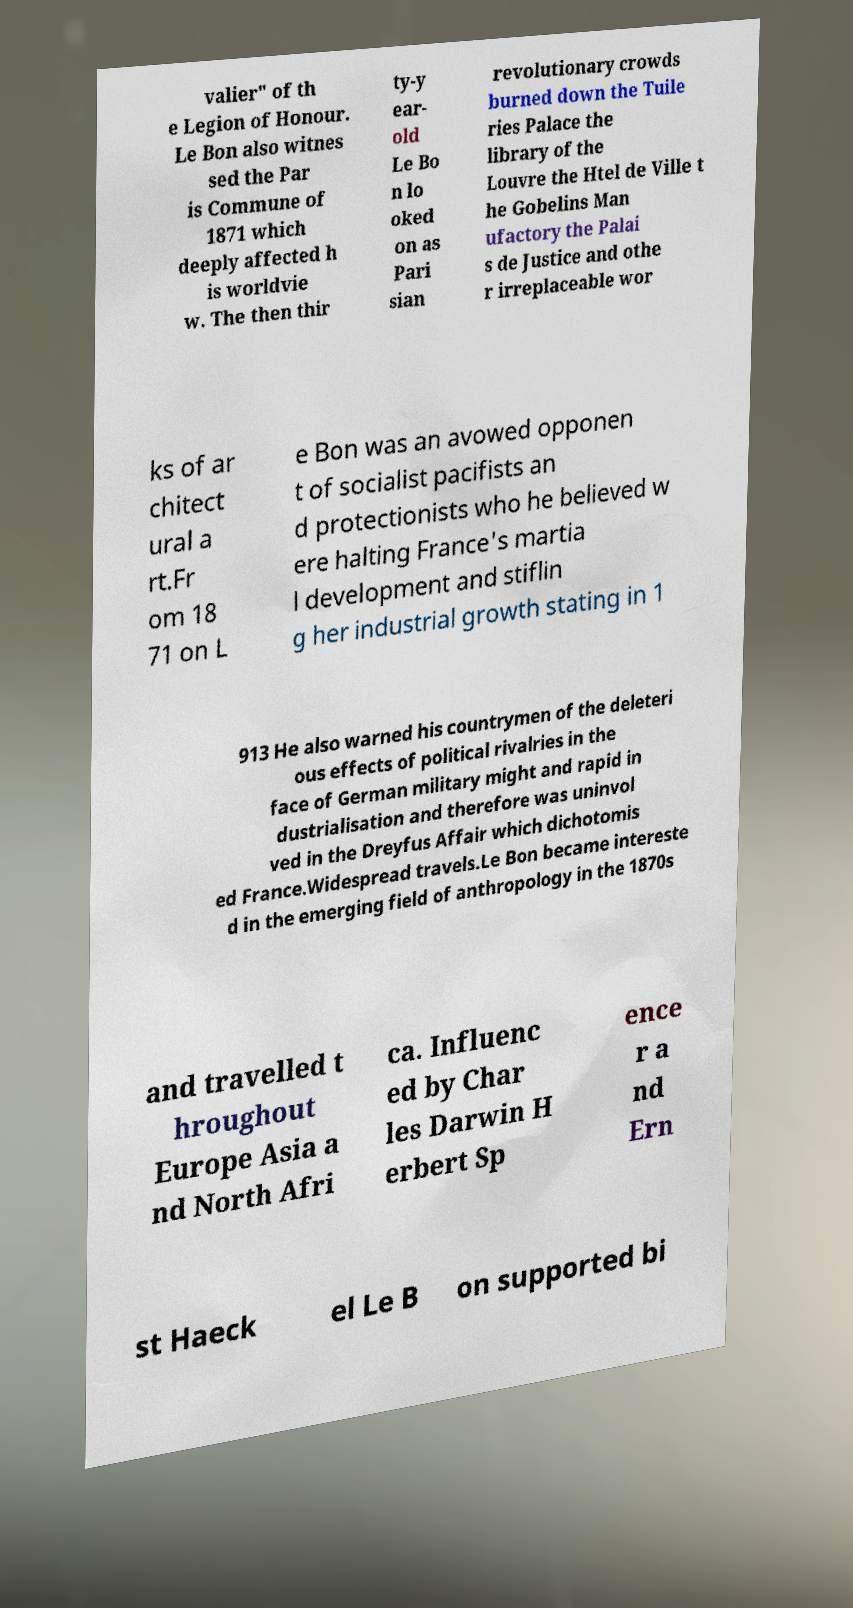Can you read and provide the text displayed in the image?This photo seems to have some interesting text. Can you extract and type it out for me? valier" of th e Legion of Honour. Le Bon also witnes sed the Par is Commune of 1871 which deeply affected h is worldvie w. The then thir ty-y ear- old Le Bo n lo oked on as Pari sian revolutionary crowds burned down the Tuile ries Palace the library of the Louvre the Htel de Ville t he Gobelins Man ufactory the Palai s de Justice and othe r irreplaceable wor ks of ar chitect ural a rt.Fr om 18 71 on L e Bon was an avowed opponen t of socialist pacifists an d protectionists who he believed w ere halting France's martia l development and stiflin g her industrial growth stating in 1 913 He also warned his countrymen of the deleteri ous effects of political rivalries in the face of German military might and rapid in dustrialisation and therefore was uninvol ved in the Dreyfus Affair which dichotomis ed France.Widespread travels.Le Bon became intereste d in the emerging field of anthropology in the 1870s and travelled t hroughout Europe Asia a nd North Afri ca. Influenc ed by Char les Darwin H erbert Sp ence r a nd Ern st Haeck el Le B on supported bi 